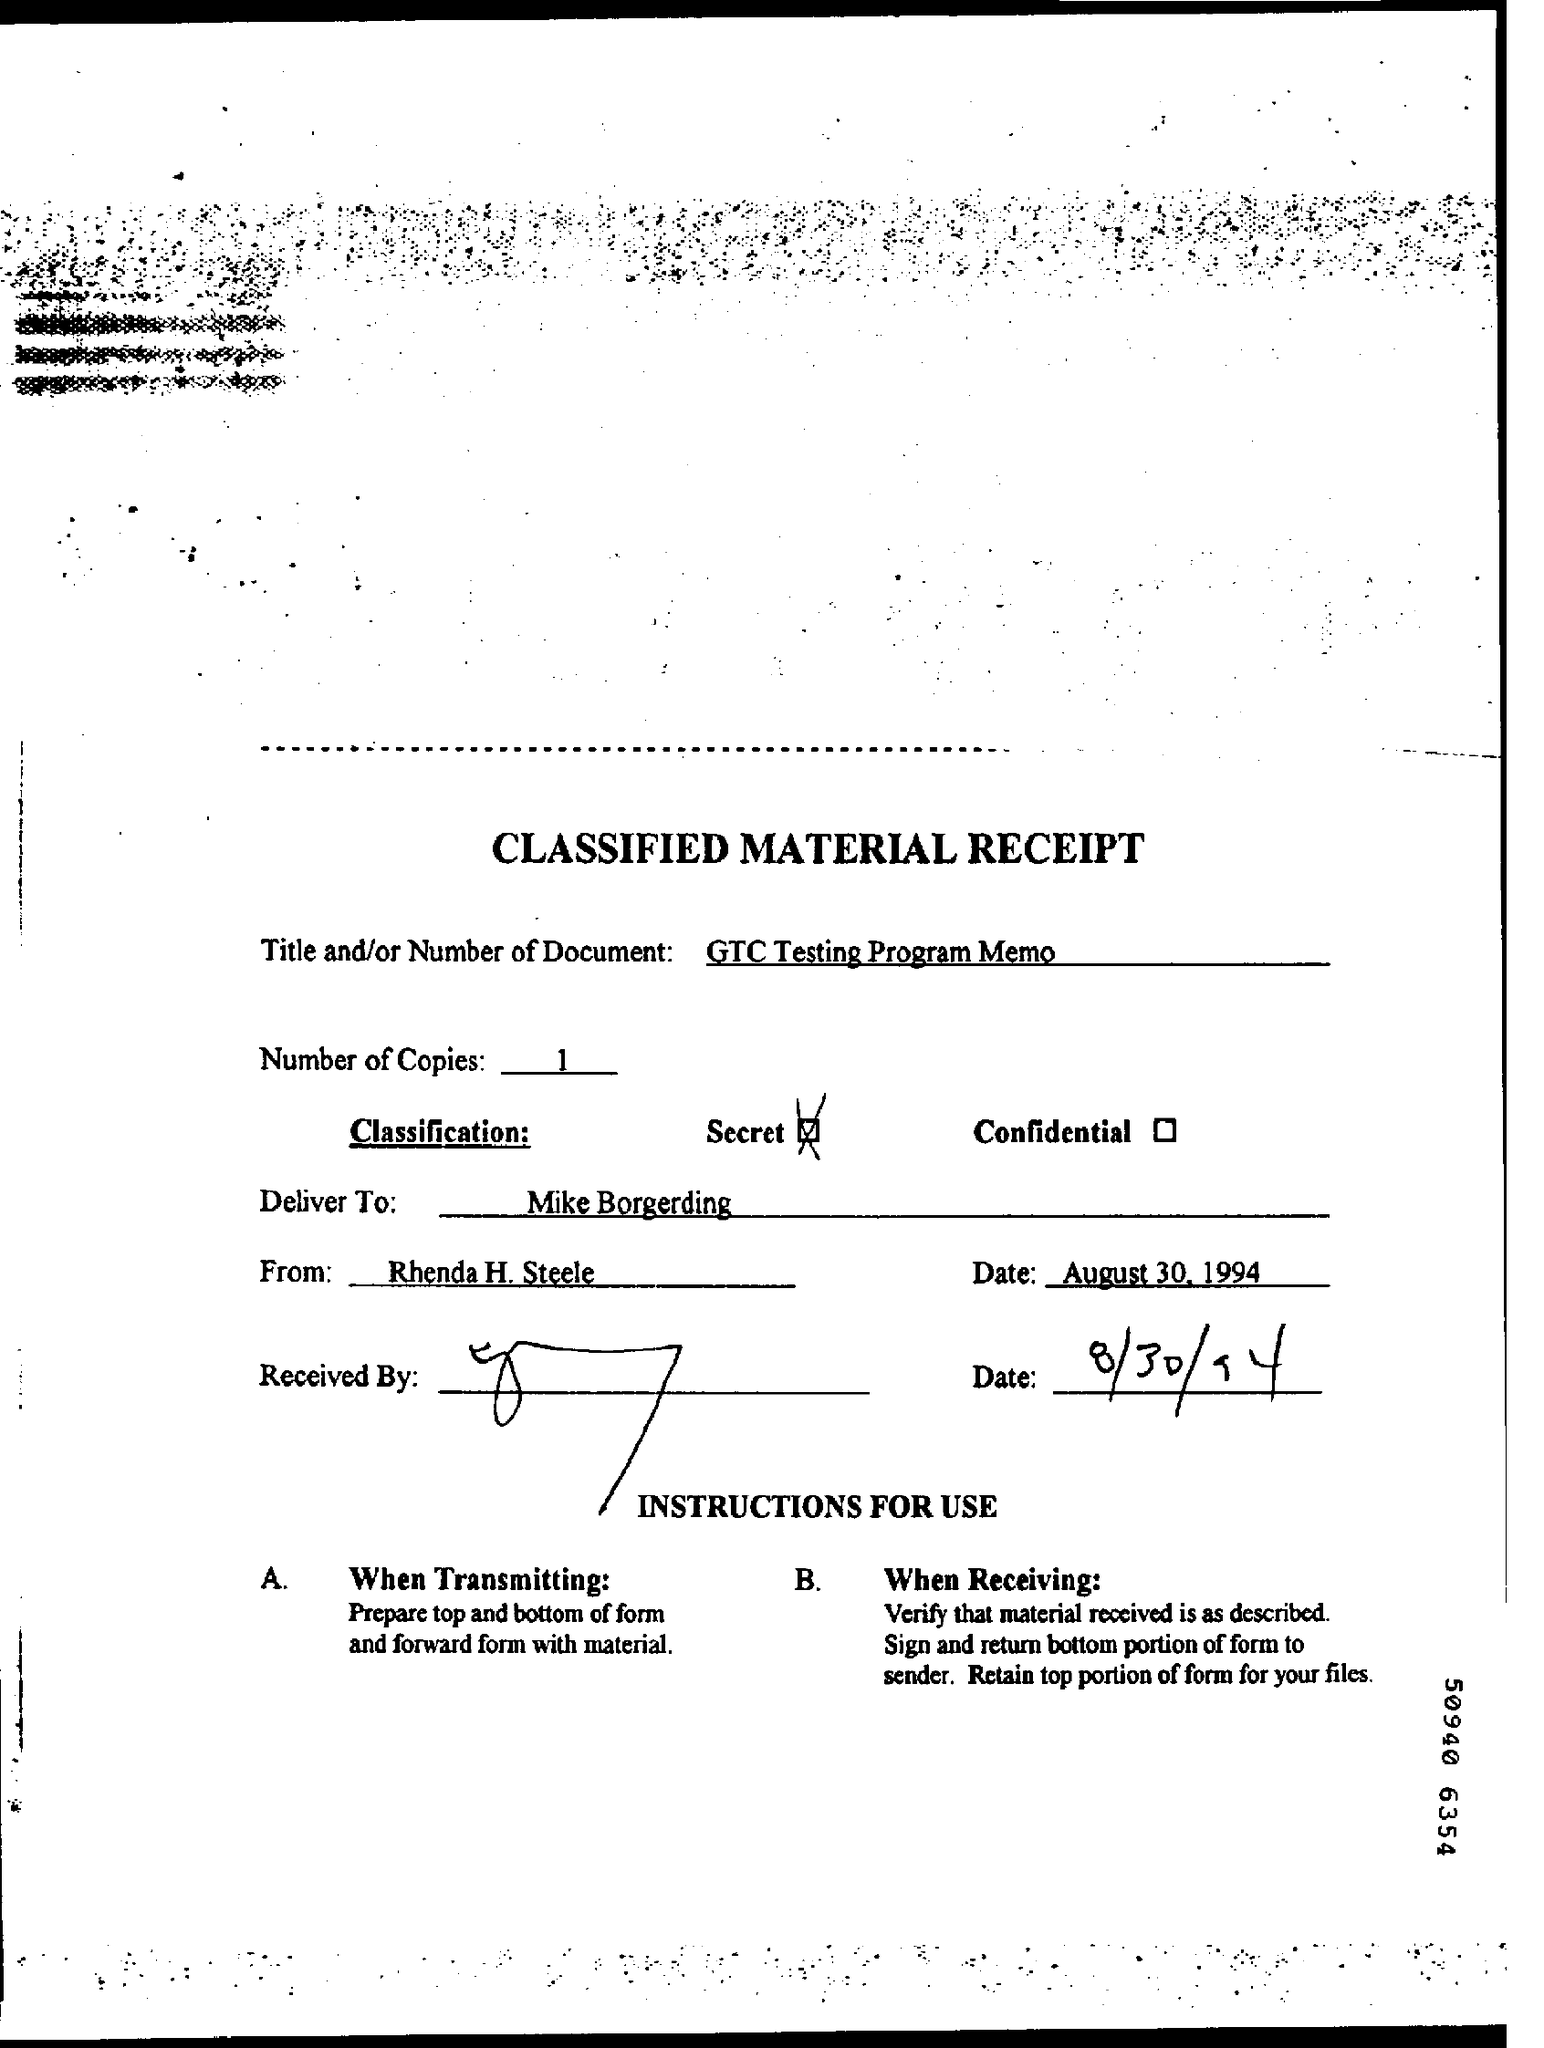Identify some key points in this picture. The memorandum is from Rhenda H. Steele. The received date is August 30, 1994. There is one copy and 1.. The memorandum is addressed to Mike Borgerding. The title field contains the written phrase "What is written in the Title Field ? GTC Testing Program Memo..". 